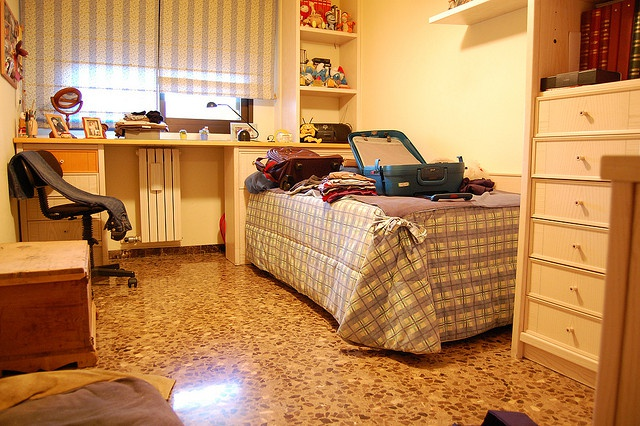Describe the objects in this image and their specific colors. I can see bed in orange, brown, tan, gray, and black tones, suitcase in orange, black, tan, and gray tones, chair in orange, black, maroon, and brown tones, backpack in orange, black, maroon, and brown tones, and book in orange, maroon, black, and olive tones in this image. 